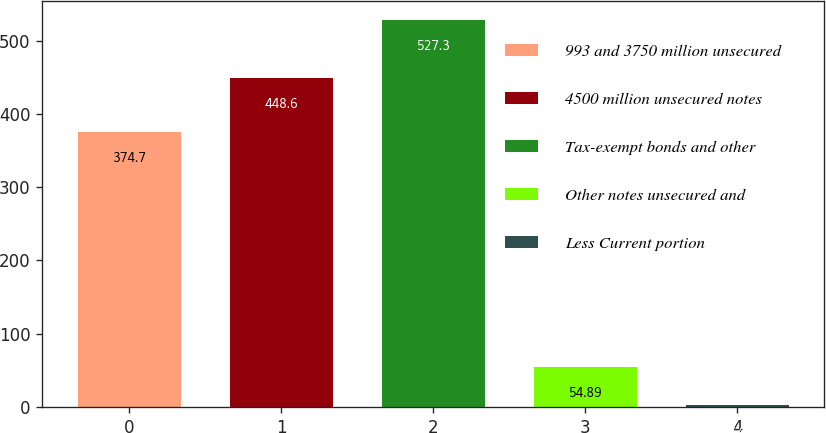Convert chart. <chart><loc_0><loc_0><loc_500><loc_500><bar_chart><fcel>993 and 3750 million unsecured<fcel>4500 million unsecured notes<fcel>Tax-exempt bonds and other<fcel>Other notes unsecured and<fcel>Less Current portion<nl><fcel>374.7<fcel>448.6<fcel>527.3<fcel>54.89<fcel>2.4<nl></chart> 